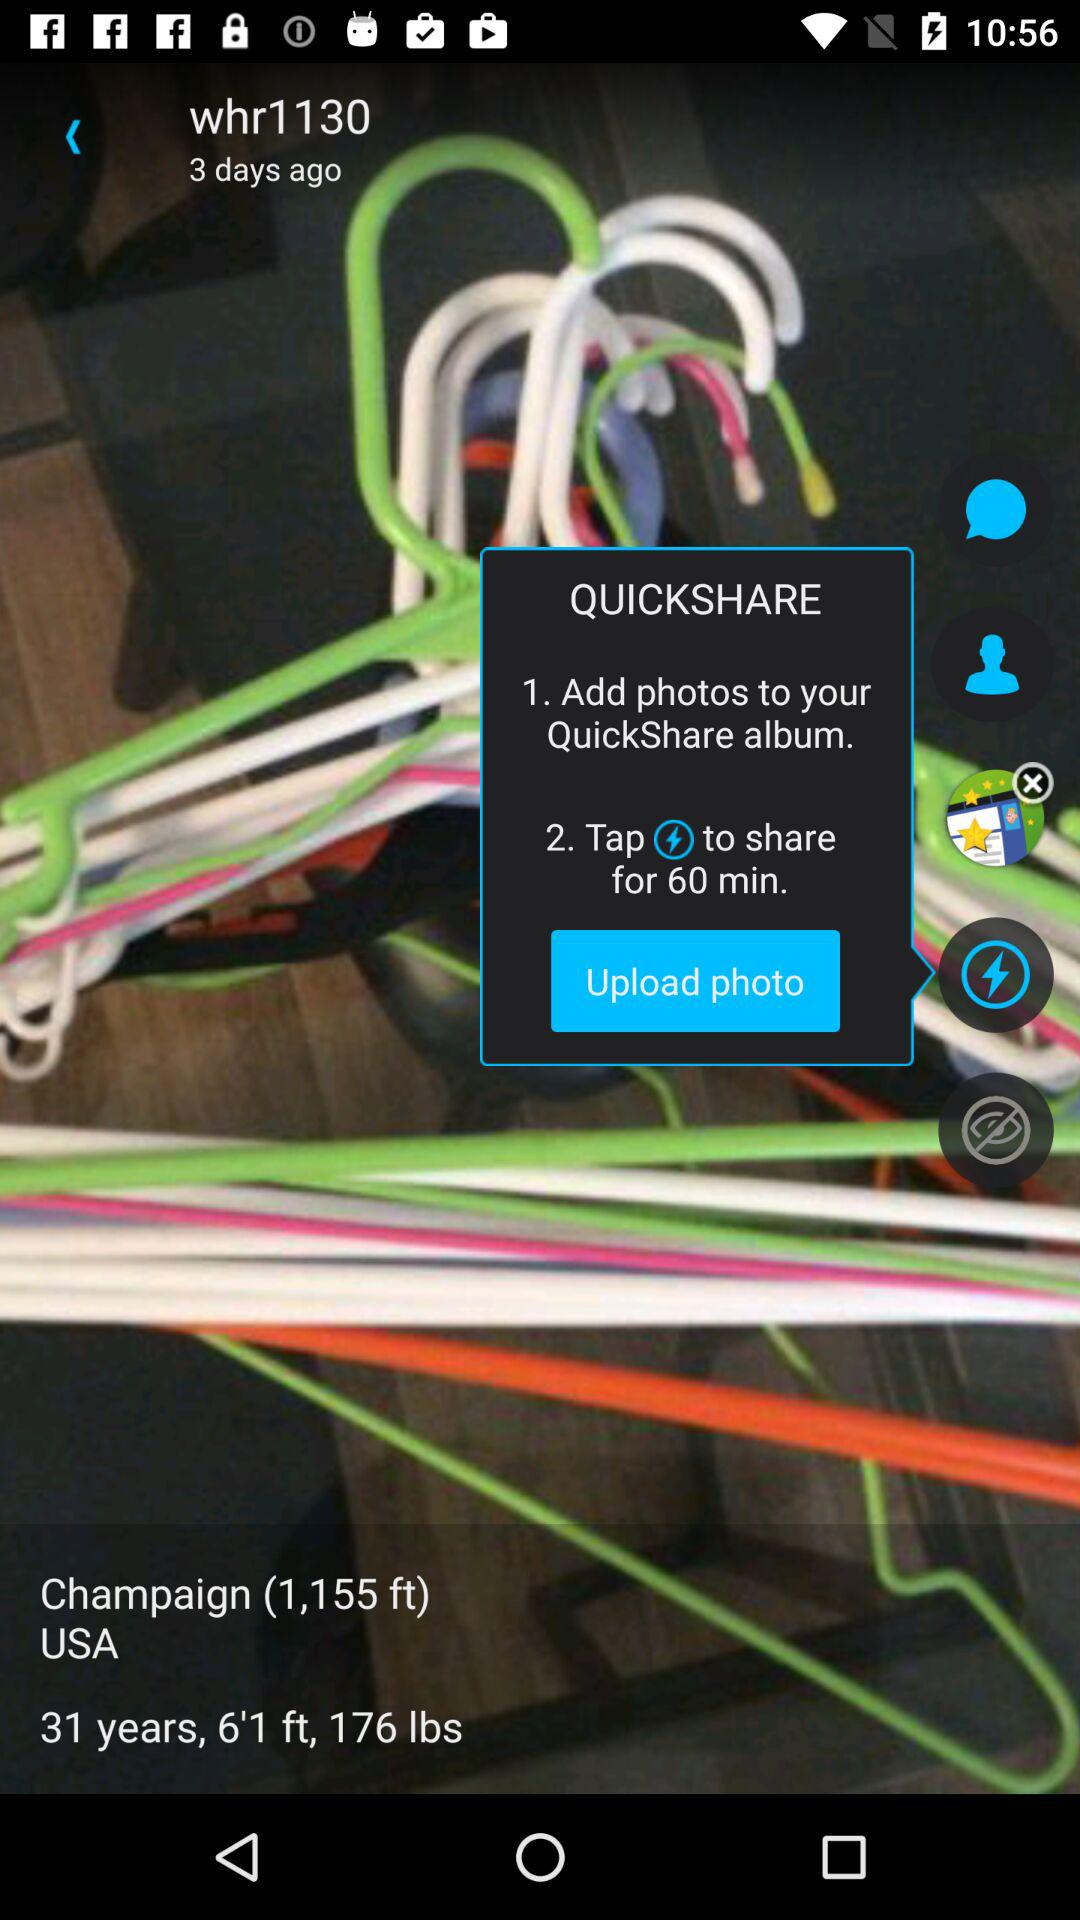What is Quickshare?
When the provided information is insufficient, respond with <no answer>. <no answer> 